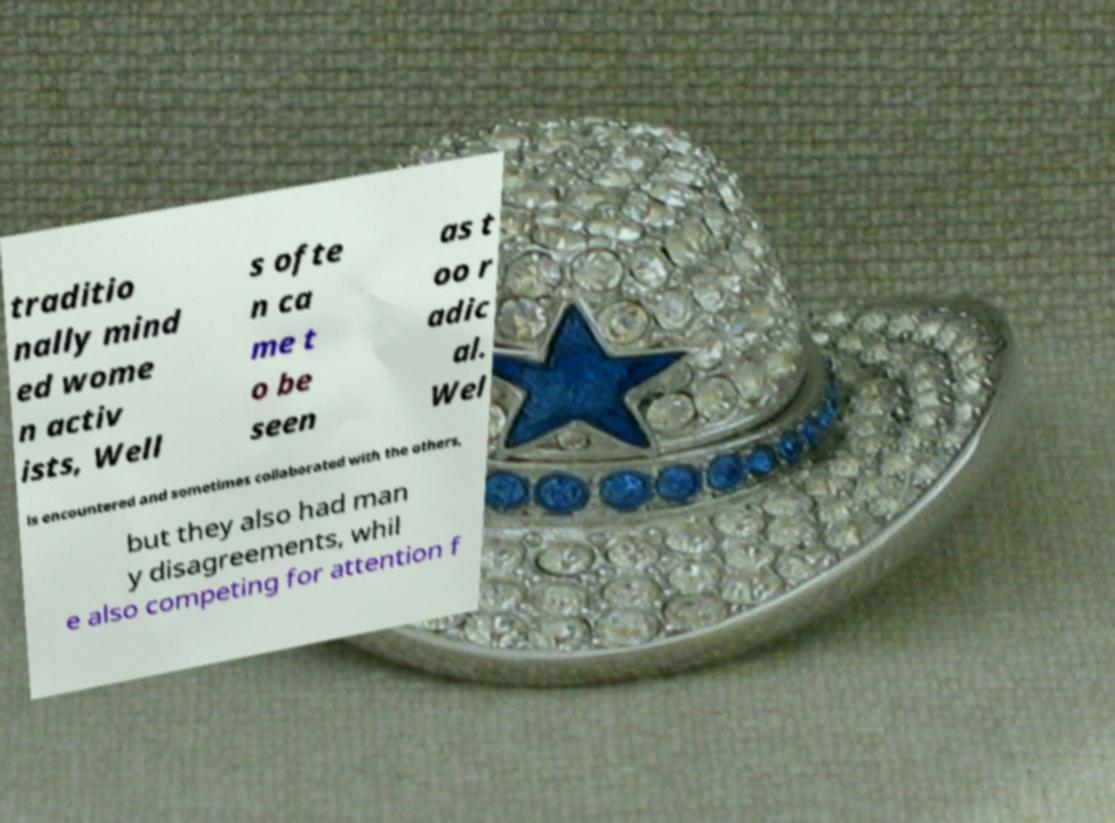Please identify and transcribe the text found in this image. traditio nally mind ed wome n activ ists, Well s ofte n ca me t o be seen as t oo r adic al. Wel ls encountered and sometimes collaborated with the others, but they also had man y disagreements, whil e also competing for attention f 